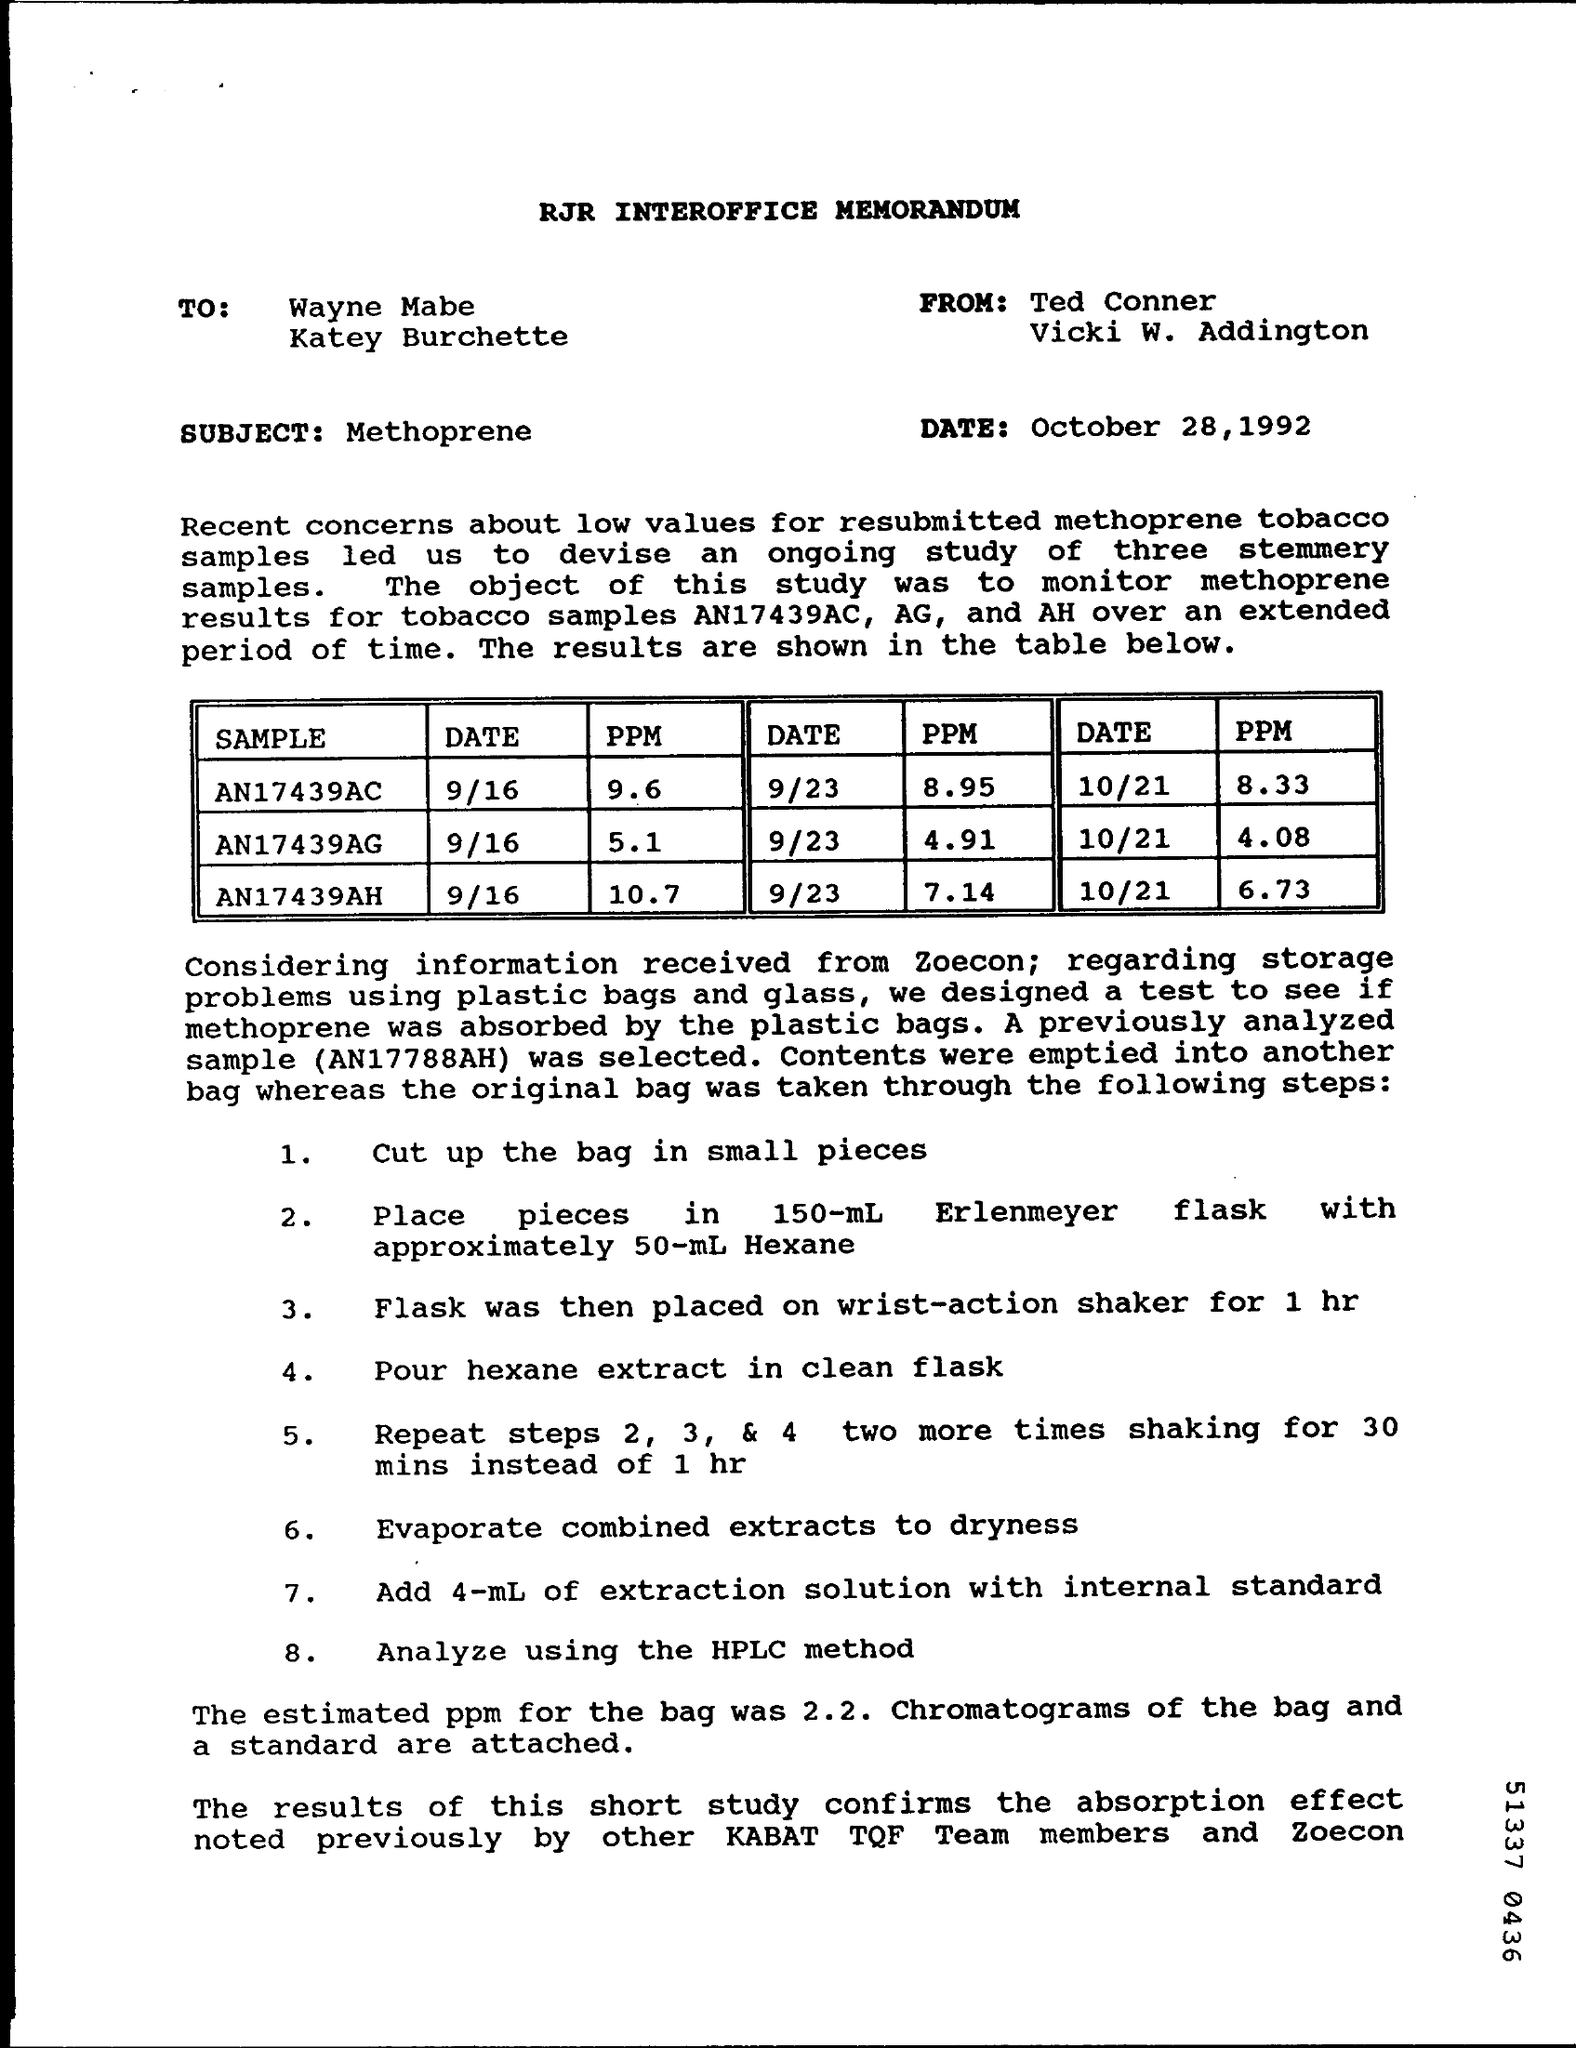Highlight a few significant elements in this photo. The estimated ppm for this bag is 2.2%. The ppm (parts per million) for sample AN17439AC on September 16th was 9.6. The subject of the document is Methoprene. 